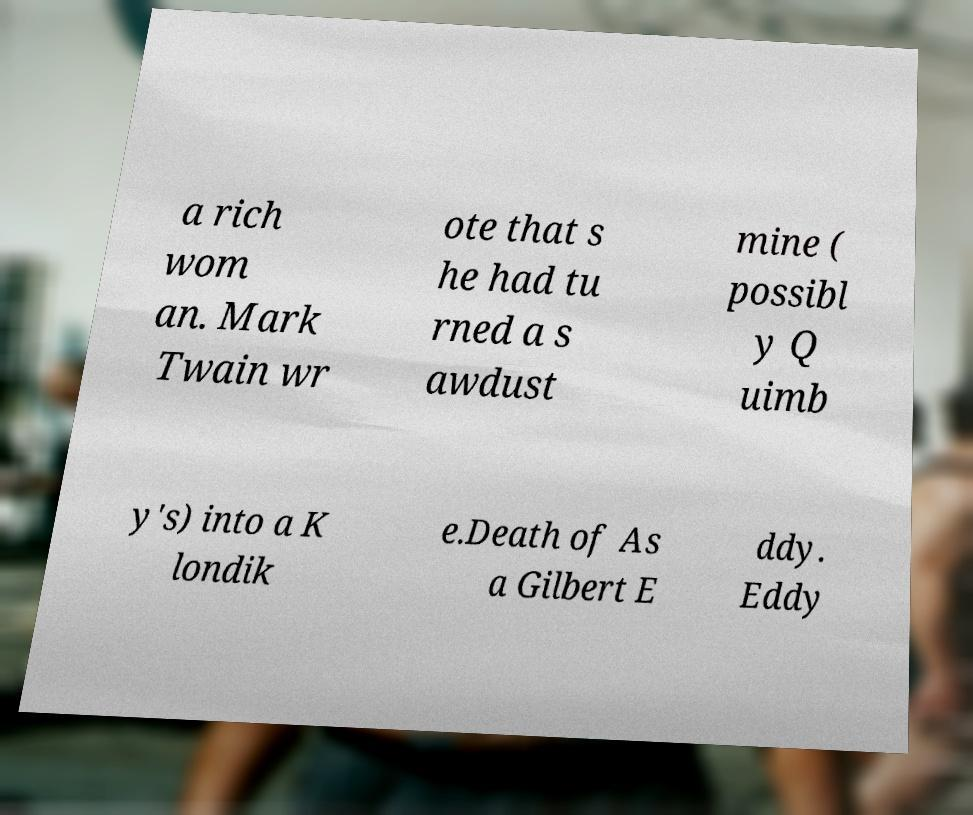Can you accurately transcribe the text from the provided image for me? a rich wom an. Mark Twain wr ote that s he had tu rned a s awdust mine ( possibl y Q uimb y's) into a K londik e.Death of As a Gilbert E ddy. Eddy 